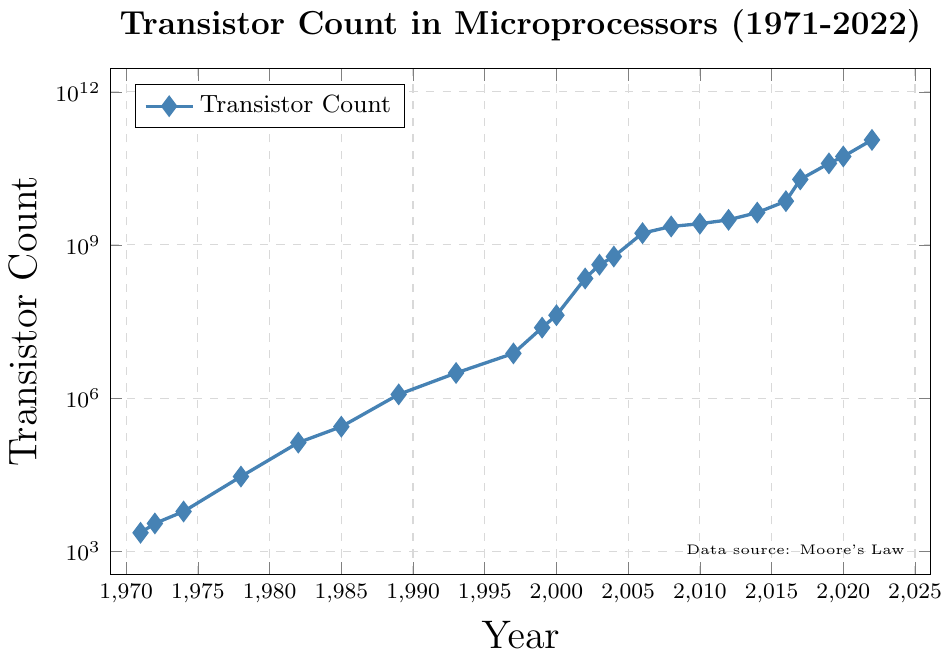What's the transistor count in microprocessors in 2022? Look at the point on the graph corresponding to the year 2022. The y-axis value is around 114000000000.
Answer: 114000000000 How did the transistor count change from 1989 to 1993? In 1989, the transistor count was 1180000. In 1993, it was 3100000. The change is 3100000 - 1180000 = 1920000.
Answer: 1920000 increase Which year saw the largest jump in transistor count? By scanning the graph and looking for the steepest rise between points, the jump from 2002 (220000000) to 2003 (410000000) is the largest. This difference is 410000000 - 220000000 = 190000000.
Answer: 2003 What is the trend in the transistor count from 1971 to 2022? The figure shows a generally exponential growth trend, as indicated by the straight line on a log scale graph with some fluctuations.
Answer: Exponential growth Which two consecutive years had almost no change in transistor count? By examining closely the graph and looking for nearly horizontal segments, the years 2010 (2600000000) and 2012 (3100000000) show minimal relative change. The difference is 3100000000 - 2600000000 = 500000000.
Answer: 2010 and 2012 During which period did the transistor count exceed 1 billion for the first time? Use the y-axis and find where the count first exceeds $10^9$ (1 billion). This happens between 1989 (1180000) and 1993 (3100000), so it is reached in 1989.
Answer: 1989 Does the figure support Moore's Law, which suggests that the transistor count doubles approximately every two years? Visualize the data points: initially, the count seems to double or more every two years. However, after 2012, the pace accelerates beyond the expected doubling every two years.
Answer: Yes, with exceptions What's the average transistor count from 2000 to 2010? Pick the points for 2000, 2002, 2003, 2004, 2006, 2008, 2010: (42000000, 220000000, 410000000, 592000000, 1700000000, 2300000000, 2600000000). Sum these up: 42000000 + 220000000 + 410000000 + 592000000 + 1700000000 + 2300000000 + 2600000000 = 8152000000. There are 7 data points, so average is 8152000000 / 7 ≈ 1164571428.6
Answer: 1164571428.6 What was the transistor count in 1997 and how does it compare to that in 2017? In 1997, the count was 7500000. In 2017, it was 19200000000. Comparing these, 19200000000 / 7500000 ≈ 2560 times larger.
Answer: 2560 times larger 